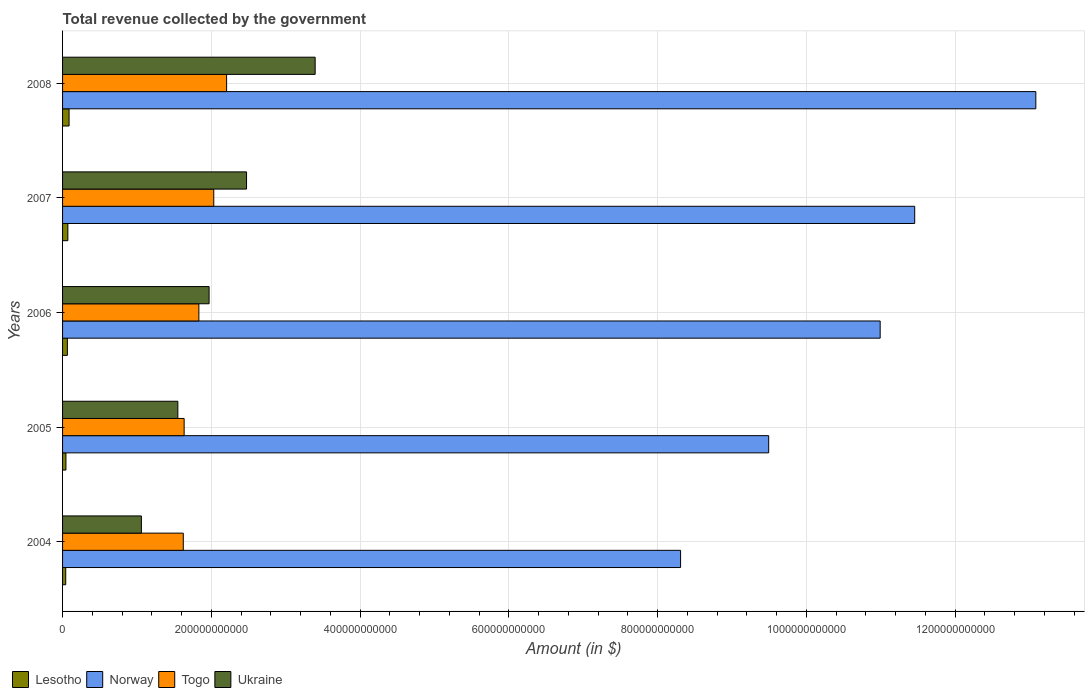How many groups of bars are there?
Your response must be concise. 5. Are the number of bars on each tick of the Y-axis equal?
Your answer should be compact. Yes. How many bars are there on the 2nd tick from the top?
Your answer should be very brief. 4. In how many cases, is the number of bars for a given year not equal to the number of legend labels?
Make the answer very short. 0. What is the total revenue collected by the government in Ukraine in 2004?
Give a very brief answer. 1.06e+11. Across all years, what is the maximum total revenue collected by the government in Togo?
Ensure brevity in your answer.  2.21e+11. Across all years, what is the minimum total revenue collected by the government in Ukraine?
Your response must be concise. 1.06e+11. In which year was the total revenue collected by the government in Norway maximum?
Keep it short and to the point. 2008. What is the total total revenue collected by the government in Togo in the graph?
Ensure brevity in your answer.  9.33e+11. What is the difference between the total revenue collected by the government in Norway in 2005 and that in 2007?
Provide a short and direct response. -1.96e+11. What is the difference between the total revenue collected by the government in Lesotho in 2004 and the total revenue collected by the government in Togo in 2006?
Give a very brief answer. -1.79e+11. What is the average total revenue collected by the government in Togo per year?
Ensure brevity in your answer.  1.87e+11. In the year 2004, what is the difference between the total revenue collected by the government in Norway and total revenue collected by the government in Ukraine?
Make the answer very short. 7.25e+11. What is the ratio of the total revenue collected by the government in Lesotho in 2005 to that in 2007?
Offer a terse response. 0.64. What is the difference between the highest and the second highest total revenue collected by the government in Ukraine?
Provide a succinct answer. 9.23e+1. What is the difference between the highest and the lowest total revenue collected by the government in Norway?
Offer a terse response. 4.78e+11. In how many years, is the total revenue collected by the government in Ukraine greater than the average total revenue collected by the government in Ukraine taken over all years?
Give a very brief answer. 2. Is the sum of the total revenue collected by the government in Togo in 2006 and 2007 greater than the maximum total revenue collected by the government in Ukraine across all years?
Your response must be concise. Yes. Is it the case that in every year, the sum of the total revenue collected by the government in Togo and total revenue collected by the government in Norway is greater than the sum of total revenue collected by the government in Ukraine and total revenue collected by the government in Lesotho?
Keep it short and to the point. Yes. What does the 1st bar from the top in 2005 represents?
Give a very brief answer. Ukraine. What does the 4th bar from the bottom in 2005 represents?
Offer a terse response. Ukraine. Is it the case that in every year, the sum of the total revenue collected by the government in Togo and total revenue collected by the government in Ukraine is greater than the total revenue collected by the government in Lesotho?
Offer a terse response. Yes. How many years are there in the graph?
Your answer should be compact. 5. What is the difference between two consecutive major ticks on the X-axis?
Offer a very short reply. 2.00e+11. Are the values on the major ticks of X-axis written in scientific E-notation?
Your answer should be compact. No. Where does the legend appear in the graph?
Ensure brevity in your answer.  Bottom left. What is the title of the graph?
Ensure brevity in your answer.  Total revenue collected by the government. Does "Channel Islands" appear as one of the legend labels in the graph?
Provide a short and direct response. No. What is the label or title of the X-axis?
Your answer should be very brief. Amount (in $). What is the label or title of the Y-axis?
Offer a very short reply. Years. What is the Amount (in $) of Lesotho in 2004?
Make the answer very short. 4.25e+09. What is the Amount (in $) in Norway in 2004?
Provide a short and direct response. 8.31e+11. What is the Amount (in $) of Togo in 2004?
Your answer should be very brief. 1.62e+11. What is the Amount (in $) in Ukraine in 2004?
Your response must be concise. 1.06e+11. What is the Amount (in $) of Lesotho in 2005?
Offer a very short reply. 4.53e+09. What is the Amount (in $) of Norway in 2005?
Your answer should be very brief. 9.49e+11. What is the Amount (in $) in Togo in 2005?
Offer a terse response. 1.63e+11. What is the Amount (in $) in Ukraine in 2005?
Offer a very short reply. 1.55e+11. What is the Amount (in $) in Lesotho in 2006?
Provide a succinct answer. 6.49e+09. What is the Amount (in $) in Norway in 2006?
Provide a short and direct response. 1.10e+12. What is the Amount (in $) of Togo in 2006?
Your answer should be compact. 1.83e+11. What is the Amount (in $) in Ukraine in 2006?
Provide a succinct answer. 1.97e+11. What is the Amount (in $) of Lesotho in 2007?
Ensure brevity in your answer.  7.13e+09. What is the Amount (in $) in Norway in 2007?
Make the answer very short. 1.15e+12. What is the Amount (in $) of Togo in 2007?
Provide a short and direct response. 2.03e+11. What is the Amount (in $) of Ukraine in 2007?
Your answer should be very brief. 2.47e+11. What is the Amount (in $) of Lesotho in 2008?
Offer a terse response. 8.76e+09. What is the Amount (in $) of Norway in 2008?
Make the answer very short. 1.31e+12. What is the Amount (in $) of Togo in 2008?
Your answer should be very brief. 2.21e+11. What is the Amount (in $) in Ukraine in 2008?
Make the answer very short. 3.40e+11. Across all years, what is the maximum Amount (in $) in Lesotho?
Offer a very short reply. 8.76e+09. Across all years, what is the maximum Amount (in $) of Norway?
Offer a very short reply. 1.31e+12. Across all years, what is the maximum Amount (in $) of Togo?
Offer a terse response. 2.21e+11. Across all years, what is the maximum Amount (in $) in Ukraine?
Your response must be concise. 3.40e+11. Across all years, what is the minimum Amount (in $) in Lesotho?
Your response must be concise. 4.25e+09. Across all years, what is the minimum Amount (in $) in Norway?
Give a very brief answer. 8.31e+11. Across all years, what is the minimum Amount (in $) of Togo?
Your answer should be very brief. 1.62e+11. Across all years, what is the minimum Amount (in $) in Ukraine?
Keep it short and to the point. 1.06e+11. What is the total Amount (in $) of Lesotho in the graph?
Offer a very short reply. 3.12e+1. What is the total Amount (in $) in Norway in the graph?
Make the answer very short. 5.33e+12. What is the total Amount (in $) of Togo in the graph?
Your response must be concise. 9.33e+11. What is the total Amount (in $) in Ukraine in the graph?
Provide a succinct answer. 1.04e+12. What is the difference between the Amount (in $) in Lesotho in 2004 and that in 2005?
Offer a terse response. -2.81e+08. What is the difference between the Amount (in $) in Norway in 2004 and that in 2005?
Provide a short and direct response. -1.18e+11. What is the difference between the Amount (in $) in Togo in 2004 and that in 2005?
Ensure brevity in your answer.  -1.16e+09. What is the difference between the Amount (in $) in Ukraine in 2004 and that in 2005?
Your response must be concise. -4.90e+1. What is the difference between the Amount (in $) in Lesotho in 2004 and that in 2006?
Provide a succinct answer. -2.23e+09. What is the difference between the Amount (in $) of Norway in 2004 and that in 2006?
Offer a terse response. -2.68e+11. What is the difference between the Amount (in $) in Togo in 2004 and that in 2006?
Make the answer very short. -2.10e+1. What is the difference between the Amount (in $) in Ukraine in 2004 and that in 2006?
Provide a short and direct response. -9.10e+1. What is the difference between the Amount (in $) of Lesotho in 2004 and that in 2007?
Provide a succinct answer. -2.87e+09. What is the difference between the Amount (in $) in Norway in 2004 and that in 2007?
Your answer should be very brief. -3.15e+11. What is the difference between the Amount (in $) in Togo in 2004 and that in 2007?
Your answer should be very brief. -4.10e+1. What is the difference between the Amount (in $) of Ukraine in 2004 and that in 2007?
Offer a very short reply. -1.41e+11. What is the difference between the Amount (in $) in Lesotho in 2004 and that in 2008?
Offer a very short reply. -4.50e+09. What is the difference between the Amount (in $) of Norway in 2004 and that in 2008?
Provide a short and direct response. -4.78e+11. What is the difference between the Amount (in $) of Togo in 2004 and that in 2008?
Offer a very short reply. -5.83e+1. What is the difference between the Amount (in $) in Ukraine in 2004 and that in 2008?
Make the answer very short. -2.34e+11. What is the difference between the Amount (in $) of Lesotho in 2005 and that in 2006?
Offer a very short reply. -1.95e+09. What is the difference between the Amount (in $) in Norway in 2005 and that in 2006?
Keep it short and to the point. -1.50e+11. What is the difference between the Amount (in $) of Togo in 2005 and that in 2006?
Your answer should be compact. -1.98e+1. What is the difference between the Amount (in $) of Ukraine in 2005 and that in 2006?
Provide a succinct answer. -4.20e+1. What is the difference between the Amount (in $) in Lesotho in 2005 and that in 2007?
Keep it short and to the point. -2.59e+09. What is the difference between the Amount (in $) in Norway in 2005 and that in 2007?
Give a very brief answer. -1.96e+11. What is the difference between the Amount (in $) of Togo in 2005 and that in 2007?
Offer a very short reply. -3.98e+1. What is the difference between the Amount (in $) in Ukraine in 2005 and that in 2007?
Your answer should be compact. -9.24e+1. What is the difference between the Amount (in $) of Lesotho in 2005 and that in 2008?
Give a very brief answer. -4.22e+09. What is the difference between the Amount (in $) in Norway in 2005 and that in 2008?
Keep it short and to the point. -3.59e+11. What is the difference between the Amount (in $) in Togo in 2005 and that in 2008?
Give a very brief answer. -5.71e+1. What is the difference between the Amount (in $) in Ukraine in 2005 and that in 2008?
Ensure brevity in your answer.  -1.85e+11. What is the difference between the Amount (in $) of Lesotho in 2006 and that in 2007?
Offer a terse response. -6.38e+08. What is the difference between the Amount (in $) in Norway in 2006 and that in 2007?
Offer a very short reply. -4.64e+1. What is the difference between the Amount (in $) of Togo in 2006 and that in 2007?
Give a very brief answer. -2.00e+1. What is the difference between the Amount (in $) in Ukraine in 2006 and that in 2007?
Give a very brief answer. -5.03e+1. What is the difference between the Amount (in $) in Lesotho in 2006 and that in 2008?
Offer a very short reply. -2.27e+09. What is the difference between the Amount (in $) of Norway in 2006 and that in 2008?
Offer a very short reply. -2.09e+11. What is the difference between the Amount (in $) in Togo in 2006 and that in 2008?
Offer a very short reply. -3.73e+1. What is the difference between the Amount (in $) of Ukraine in 2006 and that in 2008?
Offer a very short reply. -1.43e+11. What is the difference between the Amount (in $) of Lesotho in 2007 and that in 2008?
Your response must be concise. -1.63e+09. What is the difference between the Amount (in $) in Norway in 2007 and that in 2008?
Provide a short and direct response. -1.63e+11. What is the difference between the Amount (in $) in Togo in 2007 and that in 2008?
Give a very brief answer. -1.73e+1. What is the difference between the Amount (in $) in Ukraine in 2007 and that in 2008?
Provide a succinct answer. -9.23e+1. What is the difference between the Amount (in $) in Lesotho in 2004 and the Amount (in $) in Norway in 2005?
Keep it short and to the point. -9.45e+11. What is the difference between the Amount (in $) of Lesotho in 2004 and the Amount (in $) of Togo in 2005?
Give a very brief answer. -1.59e+11. What is the difference between the Amount (in $) in Lesotho in 2004 and the Amount (in $) in Ukraine in 2005?
Your response must be concise. -1.51e+11. What is the difference between the Amount (in $) in Norway in 2004 and the Amount (in $) in Togo in 2005?
Make the answer very short. 6.67e+11. What is the difference between the Amount (in $) in Norway in 2004 and the Amount (in $) in Ukraine in 2005?
Your response must be concise. 6.76e+11. What is the difference between the Amount (in $) in Togo in 2004 and the Amount (in $) in Ukraine in 2005?
Keep it short and to the point. 7.32e+09. What is the difference between the Amount (in $) in Lesotho in 2004 and the Amount (in $) in Norway in 2006?
Your answer should be compact. -1.10e+12. What is the difference between the Amount (in $) of Lesotho in 2004 and the Amount (in $) of Togo in 2006?
Your answer should be compact. -1.79e+11. What is the difference between the Amount (in $) in Lesotho in 2004 and the Amount (in $) in Ukraine in 2006?
Make the answer very short. -1.93e+11. What is the difference between the Amount (in $) in Norway in 2004 and the Amount (in $) in Togo in 2006?
Your answer should be compact. 6.48e+11. What is the difference between the Amount (in $) in Norway in 2004 and the Amount (in $) in Ukraine in 2006?
Offer a very short reply. 6.34e+11. What is the difference between the Amount (in $) in Togo in 2004 and the Amount (in $) in Ukraine in 2006?
Your answer should be compact. -3.47e+1. What is the difference between the Amount (in $) in Lesotho in 2004 and the Amount (in $) in Norway in 2007?
Your answer should be very brief. -1.14e+12. What is the difference between the Amount (in $) in Lesotho in 2004 and the Amount (in $) in Togo in 2007?
Keep it short and to the point. -1.99e+11. What is the difference between the Amount (in $) in Lesotho in 2004 and the Amount (in $) in Ukraine in 2007?
Your answer should be very brief. -2.43e+11. What is the difference between the Amount (in $) in Norway in 2004 and the Amount (in $) in Togo in 2007?
Your answer should be compact. 6.28e+11. What is the difference between the Amount (in $) of Norway in 2004 and the Amount (in $) of Ukraine in 2007?
Your response must be concise. 5.84e+11. What is the difference between the Amount (in $) of Togo in 2004 and the Amount (in $) of Ukraine in 2007?
Provide a short and direct response. -8.51e+1. What is the difference between the Amount (in $) in Lesotho in 2004 and the Amount (in $) in Norway in 2008?
Keep it short and to the point. -1.30e+12. What is the difference between the Amount (in $) of Lesotho in 2004 and the Amount (in $) of Togo in 2008?
Provide a succinct answer. -2.16e+11. What is the difference between the Amount (in $) in Lesotho in 2004 and the Amount (in $) in Ukraine in 2008?
Make the answer very short. -3.35e+11. What is the difference between the Amount (in $) in Norway in 2004 and the Amount (in $) in Togo in 2008?
Your answer should be compact. 6.10e+11. What is the difference between the Amount (in $) in Norway in 2004 and the Amount (in $) in Ukraine in 2008?
Provide a short and direct response. 4.91e+11. What is the difference between the Amount (in $) in Togo in 2004 and the Amount (in $) in Ukraine in 2008?
Offer a very short reply. -1.77e+11. What is the difference between the Amount (in $) of Lesotho in 2005 and the Amount (in $) of Norway in 2006?
Ensure brevity in your answer.  -1.09e+12. What is the difference between the Amount (in $) of Lesotho in 2005 and the Amount (in $) of Togo in 2006?
Keep it short and to the point. -1.79e+11. What is the difference between the Amount (in $) of Lesotho in 2005 and the Amount (in $) of Ukraine in 2006?
Provide a short and direct response. -1.92e+11. What is the difference between the Amount (in $) of Norway in 2005 and the Amount (in $) of Togo in 2006?
Your answer should be compact. 7.66e+11. What is the difference between the Amount (in $) in Norway in 2005 and the Amount (in $) in Ukraine in 2006?
Provide a short and direct response. 7.52e+11. What is the difference between the Amount (in $) in Togo in 2005 and the Amount (in $) in Ukraine in 2006?
Keep it short and to the point. -3.35e+1. What is the difference between the Amount (in $) in Lesotho in 2005 and the Amount (in $) in Norway in 2007?
Your response must be concise. -1.14e+12. What is the difference between the Amount (in $) of Lesotho in 2005 and the Amount (in $) of Togo in 2007?
Provide a succinct answer. -1.99e+11. What is the difference between the Amount (in $) of Lesotho in 2005 and the Amount (in $) of Ukraine in 2007?
Your response must be concise. -2.43e+11. What is the difference between the Amount (in $) in Norway in 2005 and the Amount (in $) in Togo in 2007?
Provide a short and direct response. 7.46e+11. What is the difference between the Amount (in $) of Norway in 2005 and the Amount (in $) of Ukraine in 2007?
Provide a succinct answer. 7.02e+11. What is the difference between the Amount (in $) in Togo in 2005 and the Amount (in $) in Ukraine in 2007?
Provide a succinct answer. -8.39e+1. What is the difference between the Amount (in $) in Lesotho in 2005 and the Amount (in $) in Norway in 2008?
Your answer should be very brief. -1.30e+12. What is the difference between the Amount (in $) of Lesotho in 2005 and the Amount (in $) of Togo in 2008?
Offer a terse response. -2.16e+11. What is the difference between the Amount (in $) of Lesotho in 2005 and the Amount (in $) of Ukraine in 2008?
Offer a very short reply. -3.35e+11. What is the difference between the Amount (in $) of Norway in 2005 and the Amount (in $) of Togo in 2008?
Offer a very short reply. 7.29e+11. What is the difference between the Amount (in $) in Norway in 2005 and the Amount (in $) in Ukraine in 2008?
Offer a terse response. 6.10e+11. What is the difference between the Amount (in $) in Togo in 2005 and the Amount (in $) in Ukraine in 2008?
Your answer should be compact. -1.76e+11. What is the difference between the Amount (in $) in Lesotho in 2006 and the Amount (in $) in Norway in 2007?
Ensure brevity in your answer.  -1.14e+12. What is the difference between the Amount (in $) in Lesotho in 2006 and the Amount (in $) in Togo in 2007?
Your answer should be compact. -1.97e+11. What is the difference between the Amount (in $) in Lesotho in 2006 and the Amount (in $) in Ukraine in 2007?
Ensure brevity in your answer.  -2.41e+11. What is the difference between the Amount (in $) of Norway in 2006 and the Amount (in $) of Togo in 2007?
Your answer should be compact. 8.96e+11. What is the difference between the Amount (in $) in Norway in 2006 and the Amount (in $) in Ukraine in 2007?
Your answer should be compact. 8.52e+11. What is the difference between the Amount (in $) of Togo in 2006 and the Amount (in $) of Ukraine in 2007?
Offer a very short reply. -6.41e+1. What is the difference between the Amount (in $) in Lesotho in 2006 and the Amount (in $) in Norway in 2008?
Make the answer very short. -1.30e+12. What is the difference between the Amount (in $) in Lesotho in 2006 and the Amount (in $) in Togo in 2008?
Offer a very short reply. -2.14e+11. What is the difference between the Amount (in $) in Lesotho in 2006 and the Amount (in $) in Ukraine in 2008?
Provide a succinct answer. -3.33e+11. What is the difference between the Amount (in $) of Norway in 2006 and the Amount (in $) of Togo in 2008?
Your response must be concise. 8.79e+11. What is the difference between the Amount (in $) of Norway in 2006 and the Amount (in $) of Ukraine in 2008?
Your answer should be compact. 7.60e+11. What is the difference between the Amount (in $) of Togo in 2006 and the Amount (in $) of Ukraine in 2008?
Your answer should be compact. -1.56e+11. What is the difference between the Amount (in $) of Lesotho in 2007 and the Amount (in $) of Norway in 2008?
Offer a terse response. -1.30e+12. What is the difference between the Amount (in $) of Lesotho in 2007 and the Amount (in $) of Togo in 2008?
Your answer should be compact. -2.13e+11. What is the difference between the Amount (in $) in Lesotho in 2007 and the Amount (in $) in Ukraine in 2008?
Offer a terse response. -3.32e+11. What is the difference between the Amount (in $) of Norway in 2007 and the Amount (in $) of Togo in 2008?
Provide a succinct answer. 9.25e+11. What is the difference between the Amount (in $) in Norway in 2007 and the Amount (in $) in Ukraine in 2008?
Your response must be concise. 8.06e+11. What is the difference between the Amount (in $) of Togo in 2007 and the Amount (in $) of Ukraine in 2008?
Offer a terse response. -1.36e+11. What is the average Amount (in $) of Lesotho per year?
Provide a succinct answer. 6.23e+09. What is the average Amount (in $) in Norway per year?
Your answer should be very brief. 1.07e+12. What is the average Amount (in $) in Togo per year?
Make the answer very short. 1.87e+11. What is the average Amount (in $) in Ukraine per year?
Ensure brevity in your answer.  2.09e+11. In the year 2004, what is the difference between the Amount (in $) in Lesotho and Amount (in $) in Norway?
Provide a short and direct response. -8.27e+11. In the year 2004, what is the difference between the Amount (in $) of Lesotho and Amount (in $) of Togo?
Make the answer very short. -1.58e+11. In the year 2004, what is the difference between the Amount (in $) in Lesotho and Amount (in $) in Ukraine?
Provide a short and direct response. -1.02e+11. In the year 2004, what is the difference between the Amount (in $) in Norway and Amount (in $) in Togo?
Your answer should be compact. 6.69e+11. In the year 2004, what is the difference between the Amount (in $) in Norway and Amount (in $) in Ukraine?
Your answer should be very brief. 7.25e+11. In the year 2004, what is the difference between the Amount (in $) of Togo and Amount (in $) of Ukraine?
Give a very brief answer. 5.63e+1. In the year 2005, what is the difference between the Amount (in $) in Lesotho and Amount (in $) in Norway?
Your answer should be very brief. -9.45e+11. In the year 2005, what is the difference between the Amount (in $) of Lesotho and Amount (in $) of Togo?
Your response must be concise. -1.59e+11. In the year 2005, what is the difference between the Amount (in $) in Lesotho and Amount (in $) in Ukraine?
Make the answer very short. -1.50e+11. In the year 2005, what is the difference between the Amount (in $) of Norway and Amount (in $) of Togo?
Provide a succinct answer. 7.86e+11. In the year 2005, what is the difference between the Amount (in $) in Norway and Amount (in $) in Ukraine?
Your response must be concise. 7.94e+11. In the year 2005, what is the difference between the Amount (in $) in Togo and Amount (in $) in Ukraine?
Provide a short and direct response. 8.48e+09. In the year 2006, what is the difference between the Amount (in $) of Lesotho and Amount (in $) of Norway?
Keep it short and to the point. -1.09e+12. In the year 2006, what is the difference between the Amount (in $) of Lesotho and Amount (in $) of Togo?
Keep it short and to the point. -1.77e+11. In the year 2006, what is the difference between the Amount (in $) of Lesotho and Amount (in $) of Ukraine?
Offer a terse response. -1.91e+11. In the year 2006, what is the difference between the Amount (in $) of Norway and Amount (in $) of Togo?
Keep it short and to the point. 9.16e+11. In the year 2006, what is the difference between the Amount (in $) of Norway and Amount (in $) of Ukraine?
Your response must be concise. 9.02e+11. In the year 2006, what is the difference between the Amount (in $) in Togo and Amount (in $) in Ukraine?
Keep it short and to the point. -1.37e+1. In the year 2007, what is the difference between the Amount (in $) of Lesotho and Amount (in $) of Norway?
Provide a short and direct response. -1.14e+12. In the year 2007, what is the difference between the Amount (in $) in Lesotho and Amount (in $) in Togo?
Your answer should be compact. -1.96e+11. In the year 2007, what is the difference between the Amount (in $) in Lesotho and Amount (in $) in Ukraine?
Provide a succinct answer. -2.40e+11. In the year 2007, what is the difference between the Amount (in $) of Norway and Amount (in $) of Togo?
Your answer should be compact. 9.42e+11. In the year 2007, what is the difference between the Amount (in $) in Norway and Amount (in $) in Ukraine?
Provide a short and direct response. 8.98e+11. In the year 2007, what is the difference between the Amount (in $) of Togo and Amount (in $) of Ukraine?
Your answer should be very brief. -4.41e+1. In the year 2008, what is the difference between the Amount (in $) of Lesotho and Amount (in $) of Norway?
Make the answer very short. -1.30e+12. In the year 2008, what is the difference between the Amount (in $) of Lesotho and Amount (in $) of Togo?
Ensure brevity in your answer.  -2.12e+11. In the year 2008, what is the difference between the Amount (in $) in Lesotho and Amount (in $) in Ukraine?
Keep it short and to the point. -3.31e+11. In the year 2008, what is the difference between the Amount (in $) in Norway and Amount (in $) in Togo?
Your answer should be compact. 1.09e+12. In the year 2008, what is the difference between the Amount (in $) in Norway and Amount (in $) in Ukraine?
Provide a succinct answer. 9.69e+11. In the year 2008, what is the difference between the Amount (in $) of Togo and Amount (in $) of Ukraine?
Make the answer very short. -1.19e+11. What is the ratio of the Amount (in $) of Lesotho in 2004 to that in 2005?
Ensure brevity in your answer.  0.94. What is the ratio of the Amount (in $) in Norway in 2004 to that in 2005?
Your answer should be compact. 0.88. What is the ratio of the Amount (in $) of Ukraine in 2004 to that in 2005?
Ensure brevity in your answer.  0.68. What is the ratio of the Amount (in $) of Lesotho in 2004 to that in 2006?
Your answer should be very brief. 0.66. What is the ratio of the Amount (in $) in Norway in 2004 to that in 2006?
Give a very brief answer. 0.76. What is the ratio of the Amount (in $) in Togo in 2004 to that in 2006?
Give a very brief answer. 0.89. What is the ratio of the Amount (in $) in Ukraine in 2004 to that in 2006?
Make the answer very short. 0.54. What is the ratio of the Amount (in $) in Lesotho in 2004 to that in 2007?
Offer a terse response. 0.6. What is the ratio of the Amount (in $) in Norway in 2004 to that in 2007?
Give a very brief answer. 0.73. What is the ratio of the Amount (in $) in Togo in 2004 to that in 2007?
Keep it short and to the point. 0.8. What is the ratio of the Amount (in $) in Ukraine in 2004 to that in 2007?
Offer a terse response. 0.43. What is the ratio of the Amount (in $) in Lesotho in 2004 to that in 2008?
Your answer should be compact. 0.49. What is the ratio of the Amount (in $) of Norway in 2004 to that in 2008?
Make the answer very short. 0.64. What is the ratio of the Amount (in $) of Togo in 2004 to that in 2008?
Your answer should be very brief. 0.74. What is the ratio of the Amount (in $) in Ukraine in 2004 to that in 2008?
Your answer should be very brief. 0.31. What is the ratio of the Amount (in $) of Lesotho in 2005 to that in 2006?
Keep it short and to the point. 0.7. What is the ratio of the Amount (in $) of Norway in 2005 to that in 2006?
Provide a succinct answer. 0.86. What is the ratio of the Amount (in $) of Togo in 2005 to that in 2006?
Your answer should be very brief. 0.89. What is the ratio of the Amount (in $) of Ukraine in 2005 to that in 2006?
Provide a succinct answer. 0.79. What is the ratio of the Amount (in $) in Lesotho in 2005 to that in 2007?
Your answer should be very brief. 0.64. What is the ratio of the Amount (in $) of Norway in 2005 to that in 2007?
Your answer should be compact. 0.83. What is the ratio of the Amount (in $) in Togo in 2005 to that in 2007?
Ensure brevity in your answer.  0.8. What is the ratio of the Amount (in $) of Ukraine in 2005 to that in 2007?
Provide a succinct answer. 0.63. What is the ratio of the Amount (in $) in Lesotho in 2005 to that in 2008?
Keep it short and to the point. 0.52. What is the ratio of the Amount (in $) in Norway in 2005 to that in 2008?
Make the answer very short. 0.73. What is the ratio of the Amount (in $) of Togo in 2005 to that in 2008?
Provide a succinct answer. 0.74. What is the ratio of the Amount (in $) in Ukraine in 2005 to that in 2008?
Offer a terse response. 0.46. What is the ratio of the Amount (in $) in Lesotho in 2006 to that in 2007?
Your answer should be very brief. 0.91. What is the ratio of the Amount (in $) of Norway in 2006 to that in 2007?
Give a very brief answer. 0.96. What is the ratio of the Amount (in $) of Togo in 2006 to that in 2007?
Provide a short and direct response. 0.9. What is the ratio of the Amount (in $) in Ukraine in 2006 to that in 2007?
Offer a terse response. 0.8. What is the ratio of the Amount (in $) of Lesotho in 2006 to that in 2008?
Your answer should be compact. 0.74. What is the ratio of the Amount (in $) of Norway in 2006 to that in 2008?
Provide a short and direct response. 0.84. What is the ratio of the Amount (in $) of Togo in 2006 to that in 2008?
Your response must be concise. 0.83. What is the ratio of the Amount (in $) in Ukraine in 2006 to that in 2008?
Your answer should be compact. 0.58. What is the ratio of the Amount (in $) in Lesotho in 2007 to that in 2008?
Offer a very short reply. 0.81. What is the ratio of the Amount (in $) of Norway in 2007 to that in 2008?
Offer a terse response. 0.88. What is the ratio of the Amount (in $) of Togo in 2007 to that in 2008?
Provide a succinct answer. 0.92. What is the ratio of the Amount (in $) in Ukraine in 2007 to that in 2008?
Provide a succinct answer. 0.73. What is the difference between the highest and the second highest Amount (in $) in Lesotho?
Ensure brevity in your answer.  1.63e+09. What is the difference between the highest and the second highest Amount (in $) in Norway?
Your answer should be very brief. 1.63e+11. What is the difference between the highest and the second highest Amount (in $) of Togo?
Provide a succinct answer. 1.73e+1. What is the difference between the highest and the second highest Amount (in $) of Ukraine?
Offer a terse response. 9.23e+1. What is the difference between the highest and the lowest Amount (in $) in Lesotho?
Your answer should be compact. 4.50e+09. What is the difference between the highest and the lowest Amount (in $) of Norway?
Provide a short and direct response. 4.78e+11. What is the difference between the highest and the lowest Amount (in $) of Togo?
Provide a short and direct response. 5.83e+1. What is the difference between the highest and the lowest Amount (in $) of Ukraine?
Make the answer very short. 2.34e+11. 